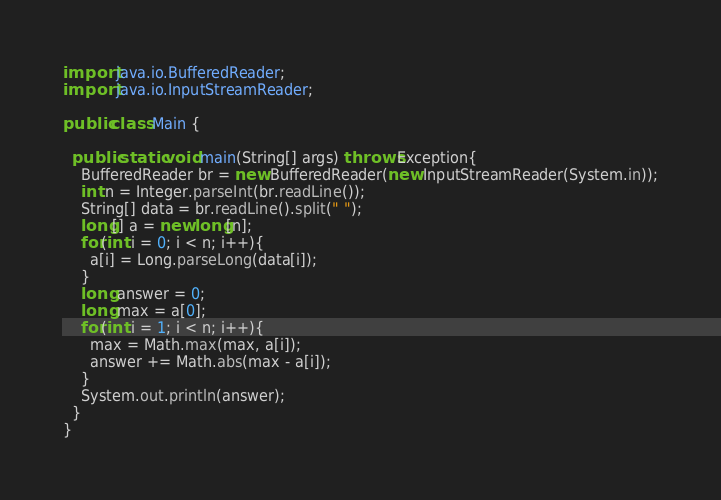Convert code to text. <code><loc_0><loc_0><loc_500><loc_500><_Java_>import java.io.BufferedReader;
import java.io.InputStreamReader;

public class Main {

  public static void main(String[] args) throws Exception{
    BufferedReader br = new BufferedReader(new InputStreamReader(System.in));
    int n = Integer.parseInt(br.readLine());
    String[] data = br.readLine().split(" ");
    long[] a = new long[n];
    for(int i = 0; i < n; i++){
      a[i] = Long.parseLong(data[i]);
    }
    long answer = 0;
    long max = a[0];
    for(int i = 1; i < n; i++){
      max = Math.max(max, a[i]);
      answer += Math.abs(max - a[i]);
    }
    System.out.println(answer);
  }
}</code> 